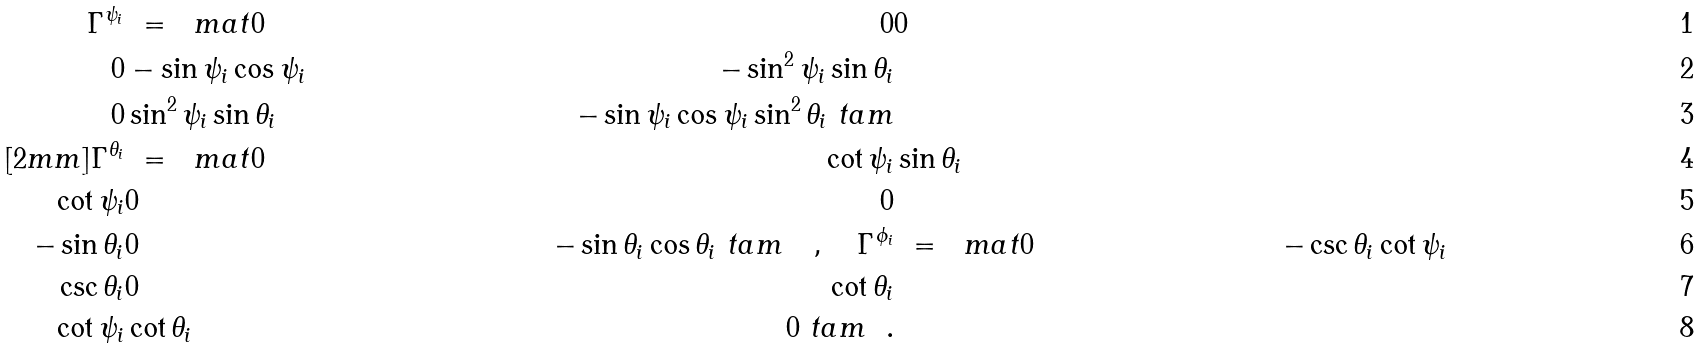<formula> <loc_0><loc_0><loc_500><loc_500>\Gamma ^ { \psi _ { i } } & \ = \ \ m a t 0 & 0 & 0 \\ 0 & - \sin \psi _ { i } \cos \psi _ { i } & - \sin ^ { 2 } \psi _ { i } \sin \theta _ { i } \\ 0 & \sin ^ { 2 } \psi _ { i } \sin \theta _ { i } & - \sin \psi _ { i } \cos \psi _ { i } \sin ^ { 2 } \theta _ { i } \ t a m \\ [ 2 m m ] \Gamma ^ { \theta _ { i } } & \ = \ \ m a t 0 & \cot \psi _ { i } & \sin \theta _ { i } \\ \cot \psi _ { i } & 0 & 0 \\ - \sin \theta _ { i } & 0 & - \sin \theta _ { i } \cos \theta _ { i } \ t a m \quad , \quad \Gamma ^ { \phi _ { i } } & \ = \ \ m a t 0 & - \csc \theta _ { i } & \cot \psi _ { i } \\ \csc \theta _ { i } & 0 & \cot \theta _ { i } \\ \cot \psi _ { i } & \cot \theta _ { i } & 0 \ t a m \ \ .</formula> 